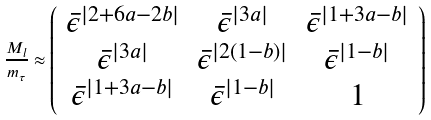<formula> <loc_0><loc_0><loc_500><loc_500>\frac { M _ { l } } { m _ { \tau } } \approx \left ( \begin{array} { c c c } \bar { \epsilon } ^ { | 2 + 6 a - 2 b | } & \bar { \epsilon } ^ { | 3 a | } & \bar { \epsilon } ^ { | 1 + 3 a - b | } \\ \bar { \epsilon } ^ { | 3 a | } & \bar { \epsilon } ^ { | 2 ( 1 - b ) | } & \bar { \epsilon } ^ { | 1 - b | } \\ \bar { \epsilon } ^ { | 1 + 3 a - b | } & \bar { \epsilon } ^ { | 1 - b | } & 1 \end{array} \right )</formula> 